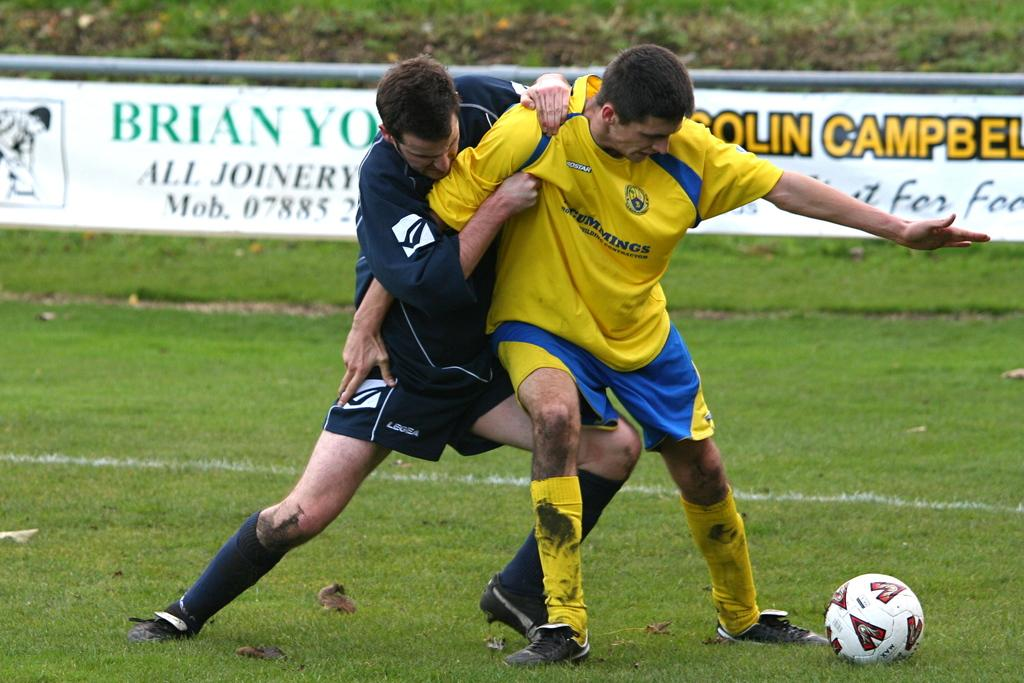How many people are in the image? There are two men in the image. What are the men wearing? The men are wearing clothes, socks, and shoes. What activity are the men engaged in? The men appear to be fighting. What object can be seen in the image besides the men? There is a ball in the image. What type of surface is visible in the image? There is grass in the image. What is on the poster in the image? There is a poster in the image with text on it. Can you see any rabbits playing in the sea in the image? There are no rabbits or sea visible in the image; it features two men fighting, a ball, grass, and a poster with text. 